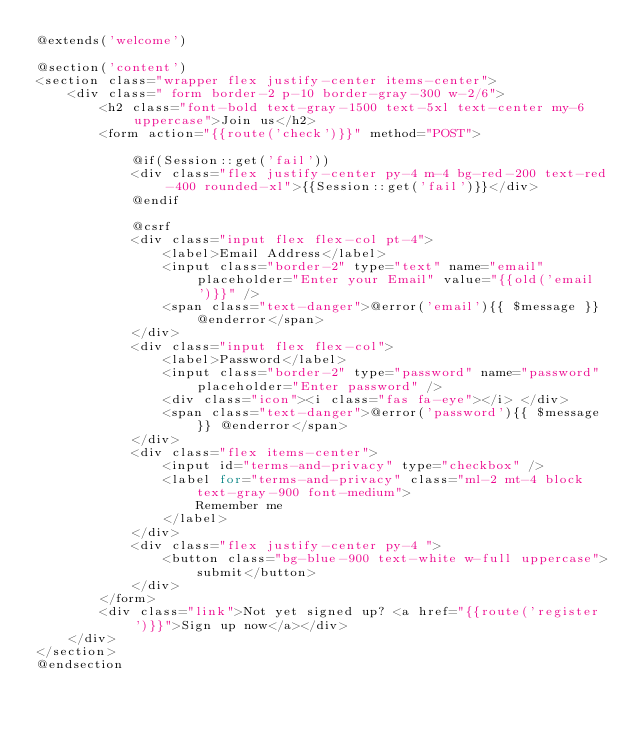Convert code to text. <code><loc_0><loc_0><loc_500><loc_500><_PHP_>@extends('welcome')

@section('content')
<section class="wrapper flex justify-center items-center">
    <div class=" form border-2 p-10 border-gray-300 w-2/6">
        <h2 class="font-bold text-gray-1500 text-5xl text-center my-6 uppercase">Join us</h2>
        <form action="{{route('check')}}" method="POST">

            @if(Session::get('fail'))
            <div class="flex justify-center py-4 m-4 bg-red-200 text-red-400 rounded-xl">{{Session::get('fail')}}</div>
            @endif

            @csrf
            <div class="input flex flex-col pt-4">
                <label>Email Address</label>
                <input class="border-2" type="text" name="email" placeholder="Enter your Email" value="{{old('email')}}" />
                <span class="text-danger">@error('email'){{ $message }} @enderror</span>
            </div>
            <div class="input flex flex-col">
                <label>Password</label>
                <input class="border-2" type="password" name="password" placeholder="Enter password" />
                <div class="icon"><i class="fas fa-eye"></i> </div>
                <span class="text-danger">@error('password'){{ $message }} @enderror</span>
            </div>
            <div class="flex items-center">
                <input id="terms-and-privacy" type="checkbox" />
                <label for="terms-and-privacy" class="ml-2 mt-4 block text-gray-900 font-medium">
                    Remember me
                </label>
            </div>
            <div class="flex justify-center py-4 ">
                <button class="bg-blue-900 text-white w-full uppercase">submit</button>
            </div>
        </form>
        <div class="link">Not yet signed up? <a href="{{route('register')}}">Sign up now</a></div>
    </div>
</section>
@endsection</code> 